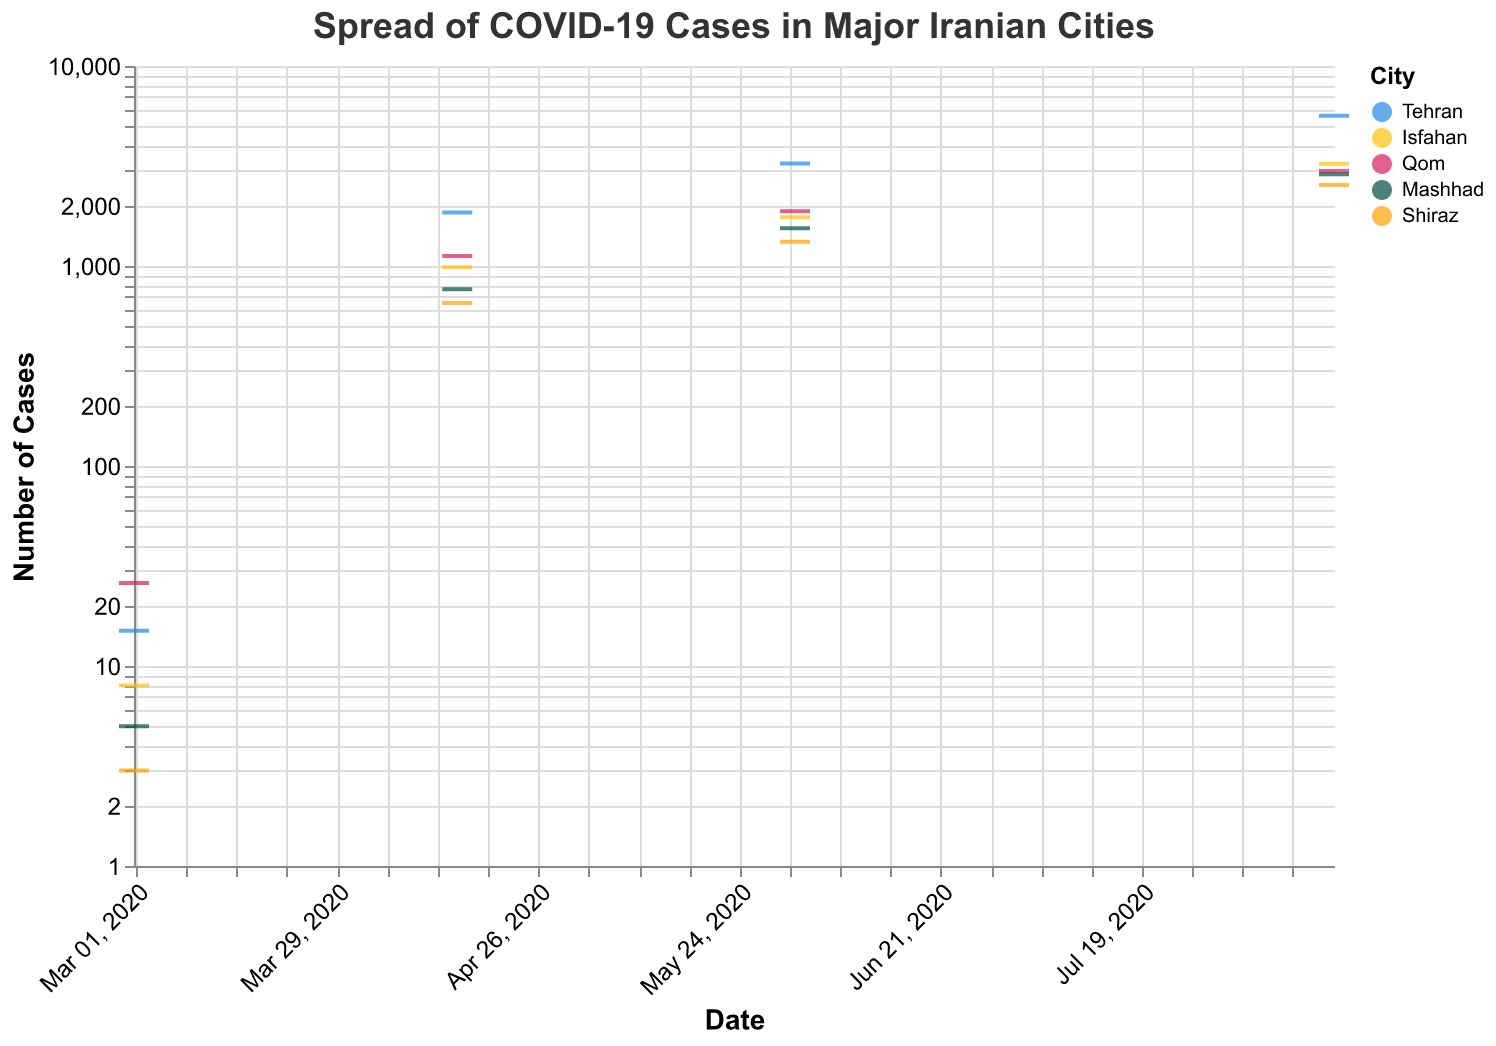What is the title of the figure? The title of the figure is displayed at the top. It provides context for what the figure is representing.
Answer: Spread of COVID-19 Cases in Major Iranian Cities How many cities are represented in the figure? The figure uses different colors to represent different cities. By looking at the legend, we can count the number of unique cities.
Answer: 5 Which city had the highest number of COVID-19 cases on August 15, 2020? By looking at the y-axis values on August 15, 2020, and comparing the tick marks associated with each city, we can identify the city with the highest number of cases.
Answer: Tehran What is the trend of COVID-19 cases in Shiraz over time? We analyze Shiraz's tick marks from March 1, 2020, to August 15, 2020, to see if the number of cases is increasing, decreasing, or stable over time.
Answer: Increasing How does the increase in COVID-19 cases in Tehran compare to that in Isfahan from March 1, 2020, to August 15, 2020? Compare the y-axis values for both Tehran and Isfahan on March 1, 2020, and August 15, 2020, and calculate the differences to compare the increase.
Answer: Tehran increased by 5617 cases, Isfahan by 3233 cases Which city had more COVID-19 cases on April 15, 2020: Qom or Mashhad? Check the y-axis values for Qom and Mashhad on April 15, 2020, and compare them to determine which city had more cases on that date.
Answer: Qom What is the ratio of COVID-19 cases in Tehran to Mashhad on June 1, 2020? Find the y-axis values for both Tehran and Mashhad on June 1, 2020, then divide the number of cases in Tehran by the number of cases in Mashhad to find the ratio.
Answer: Approximately 2.11 (3254/1543) What was the increase in COVID-19 cases in Qom from March 1, 2020, to June 1, 2020? Subtract the number of cases on March 1, 2020, from the number of cases on June 1, 2020, for the city of Qom.
Answer: 1850 Which city had the lowest number of COVID-19 cases on March 1, 2020? Look at the y-axis values for all cities on March 1, 2020, and identify the city with the smallest value.
Answer: Shiraz Did any city experience a decrease in COVID-19 cases at any point in time? Analyze the y-axis values over time for each city to see if there is any point where cases decreased.
Answer: No 